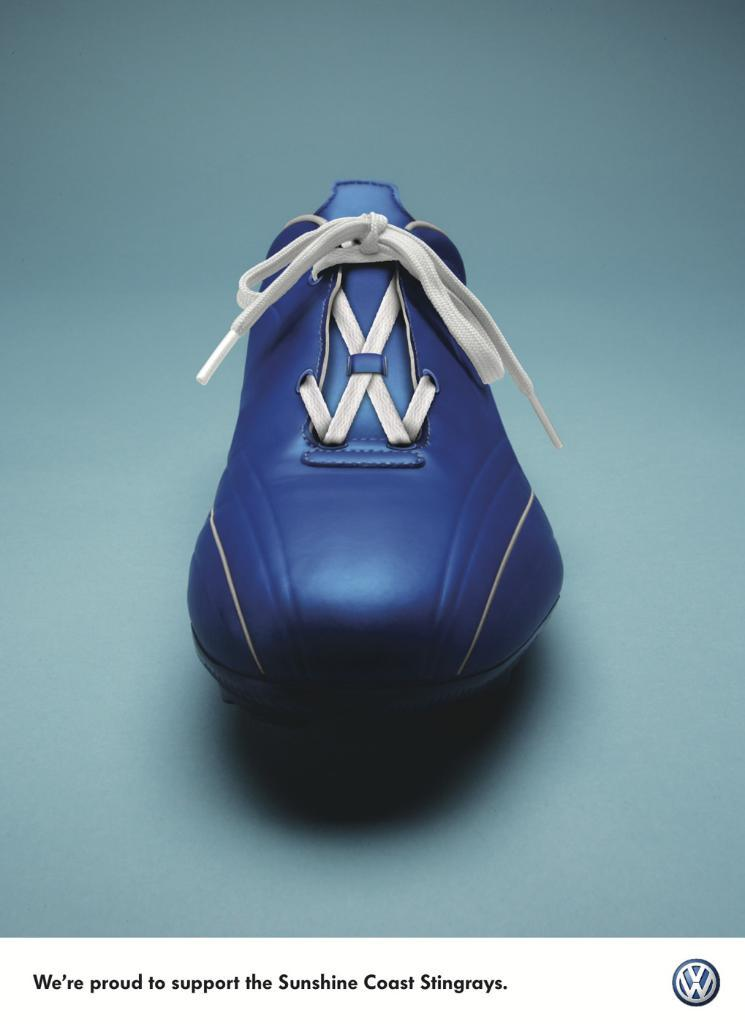<image>
Write a terse but informative summary of the picture. An ad for VW stating that they are proud to support the Sunshine Coast Stingrays. 